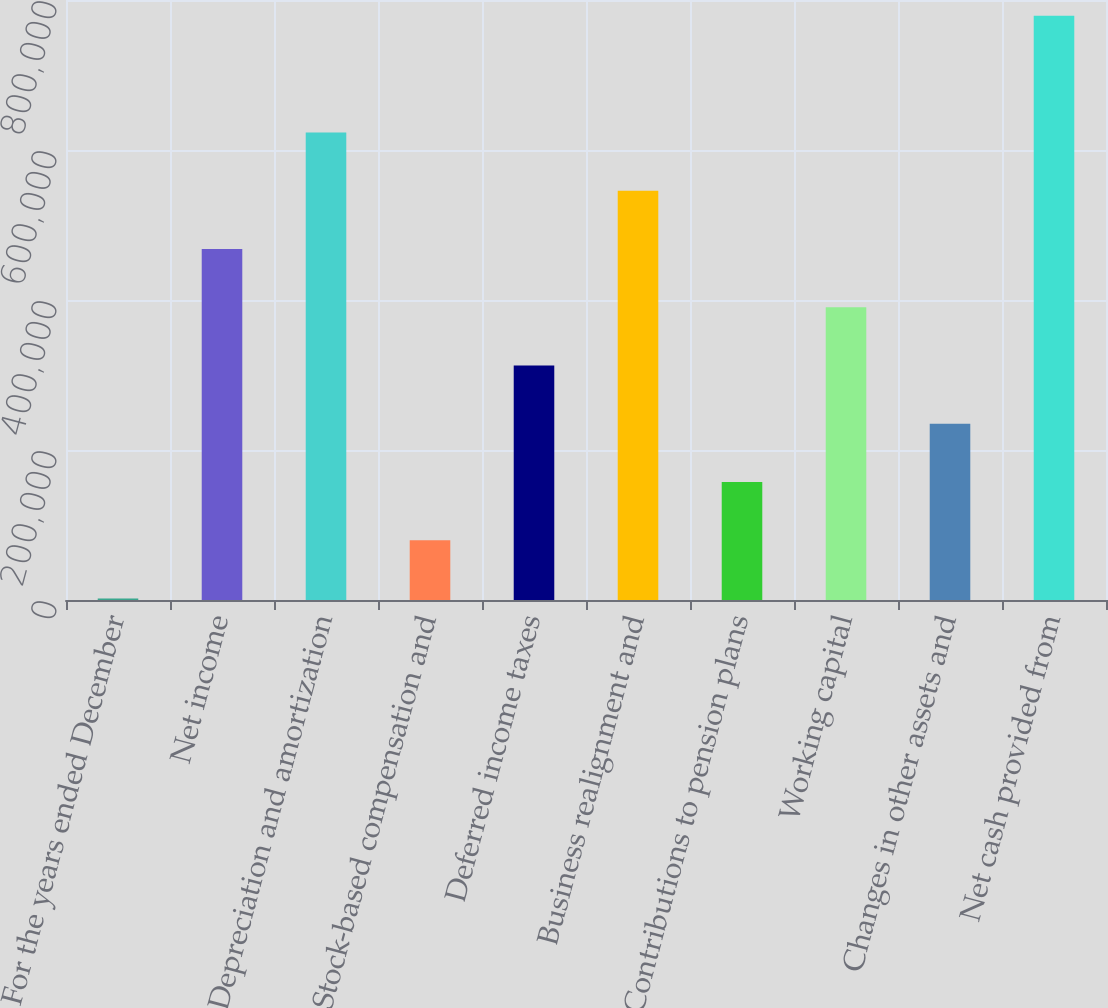Convert chart to OTSL. <chart><loc_0><loc_0><loc_500><loc_500><bar_chart><fcel>For the years ended December<fcel>Net income<fcel>Depreciation and amortization<fcel>Stock-based compensation and<fcel>Deferred income taxes<fcel>Business realignment and<fcel>Contributions to pension plans<fcel>Working capital<fcel>Changes in other assets and<fcel>Net cash provided from<nl><fcel>2007<fcel>468104<fcel>623470<fcel>79689.9<fcel>312739<fcel>545787<fcel>157373<fcel>390422<fcel>235056<fcel>778836<nl></chart> 